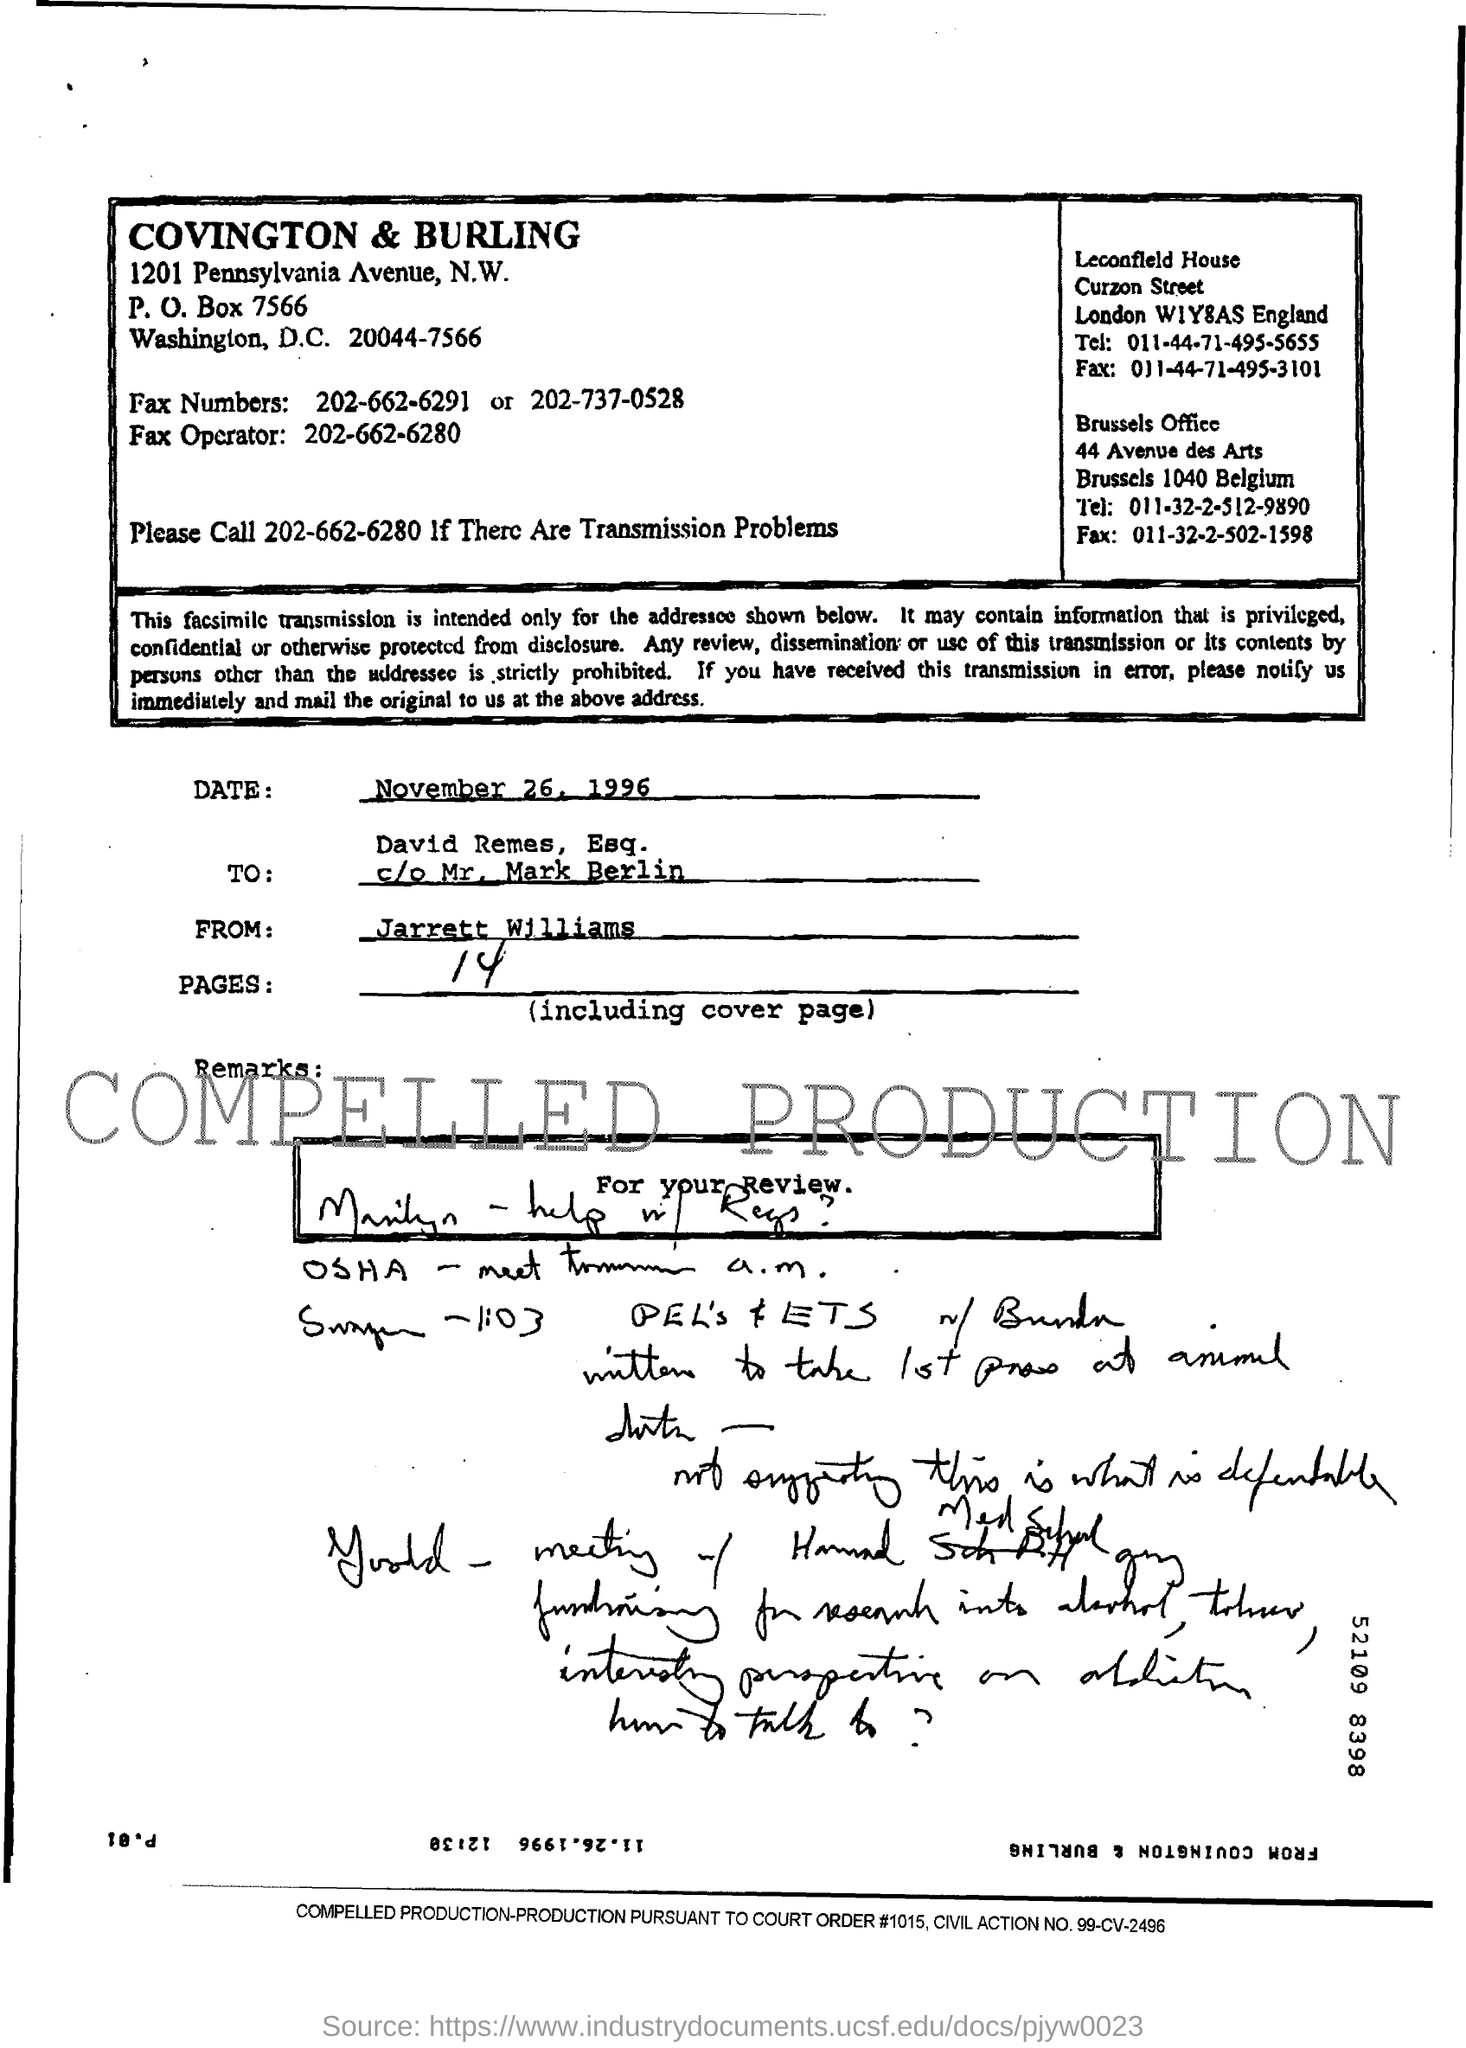What number must be called for transmission problems ?
Keep it short and to the point. 202-662-6280. Who is the sender of this fax?
Offer a terse response. Jarrett Williams. What is the p.o box number of covington & burling ?
Give a very brief answer. 7566. What is the court order #?
Your answer should be very brief. 1015. How many number of pages are there ?
Give a very brief answer. 14. 